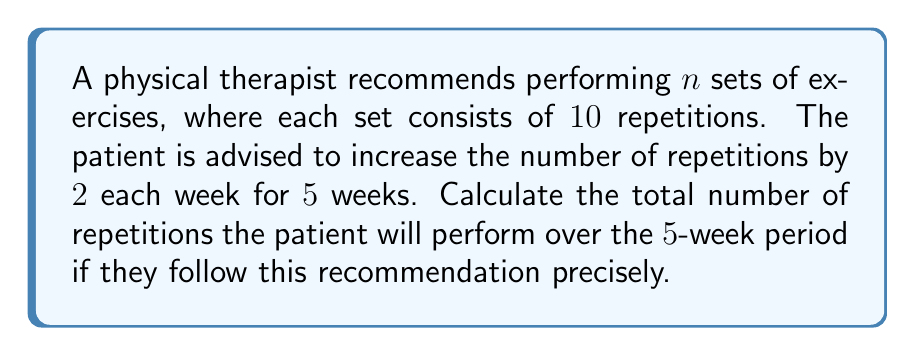Teach me how to tackle this problem. Let's approach this step-by-step:

1) In the first week, the patient performs $n$ sets of $10$ repetitions each.
   Total repetitions in week 1: $10n$

2) Each week, the number of repetitions per set increases by 2.
   Week 2: $12n$ repetitions
   Week 3: $14n$ repetitions
   Week 4: $16n$ repetitions
   Week 5: $18n$ repetitions

3) To find the total number of repetitions over 5 weeks, we sum these up:
   $$(10n + 12n + 14n + 16n + 18n)$$

4) Factor out $n$:
   $$n(10 + 12 + 14 + 16 + 18)$$

5) Sum the numbers inside the parentheses:
   $$n(70)$$

6) Simplify:
   $$70n$$

Therefore, over the 5-week period, the patient will perform a total of $70n$ repetitions.
Answer: $70n$ repetitions 